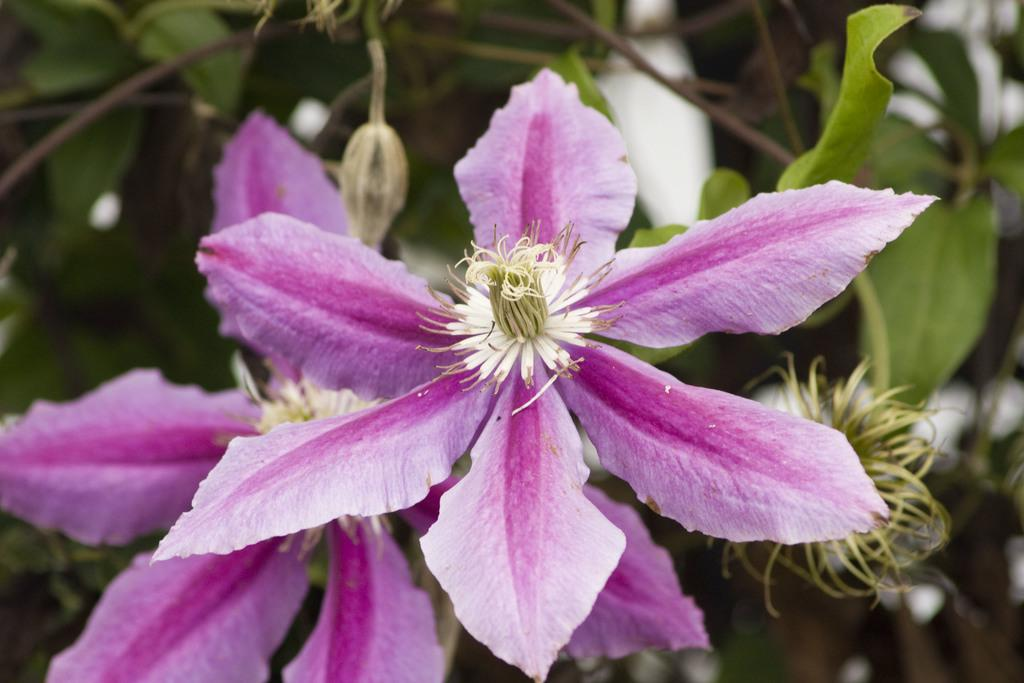What type of plant elements can be seen in the image? There are flowers, leaves, and stems in the image. Can you describe the flowers in the image? The flowers in the image have various colors and shapes. What else can be seen in the image besides the flowers? There are leaves and stems in the image. What advice can be given to the flowers in the image? There is no need to give advice to the flowers in the image, as they are not sentient beings capable of understanding or following advice. 